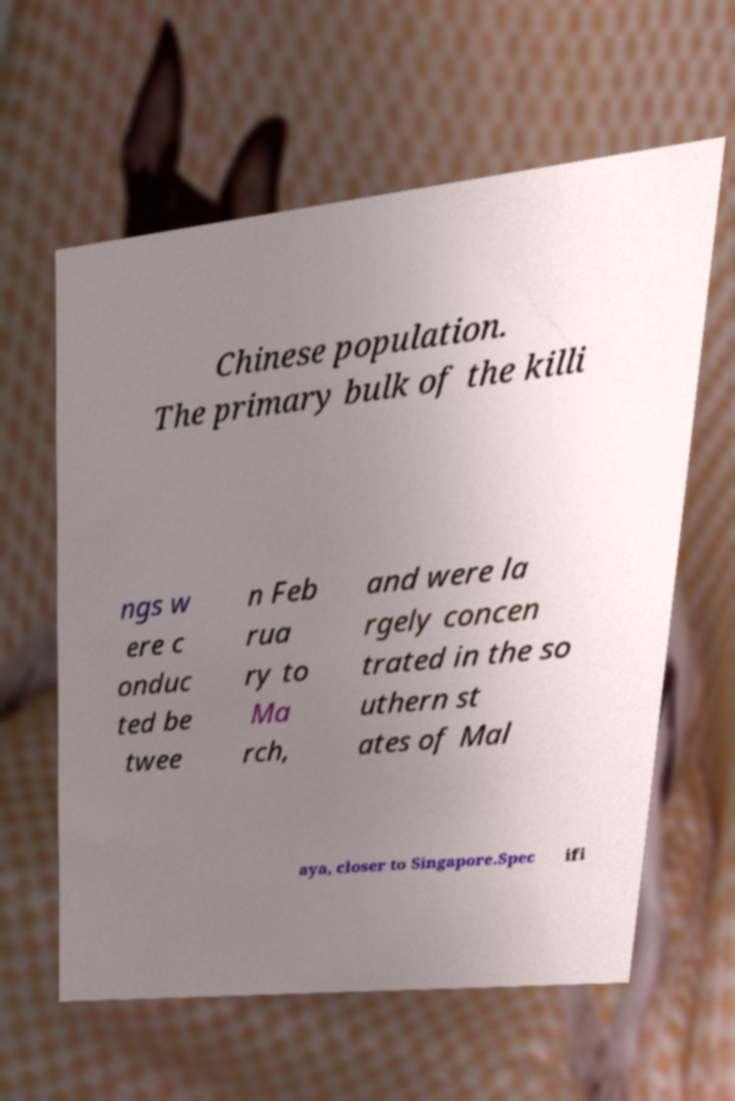What messages or text are displayed in this image? I need them in a readable, typed format. Chinese population. The primary bulk of the killi ngs w ere c onduc ted be twee n Feb rua ry to Ma rch, and were la rgely concen trated in the so uthern st ates of Mal aya, closer to Singapore.Spec ifi 